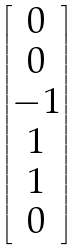Convert formula to latex. <formula><loc_0><loc_0><loc_500><loc_500>\begin{bmatrix} 0 \\ 0 \\ - 1 \\ 1 \\ 1 \\ 0 \end{bmatrix}</formula> 